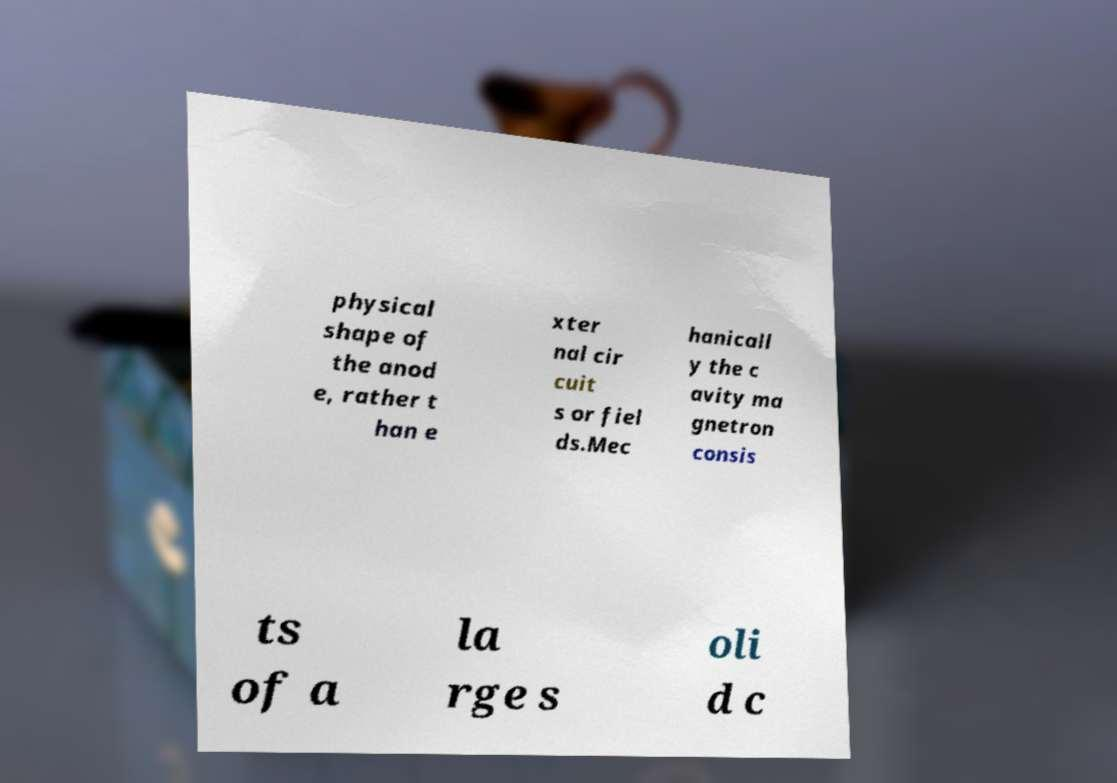Could you extract and type out the text from this image? physical shape of the anod e, rather t han e xter nal cir cuit s or fiel ds.Mec hanicall y the c avity ma gnetron consis ts of a la rge s oli d c 